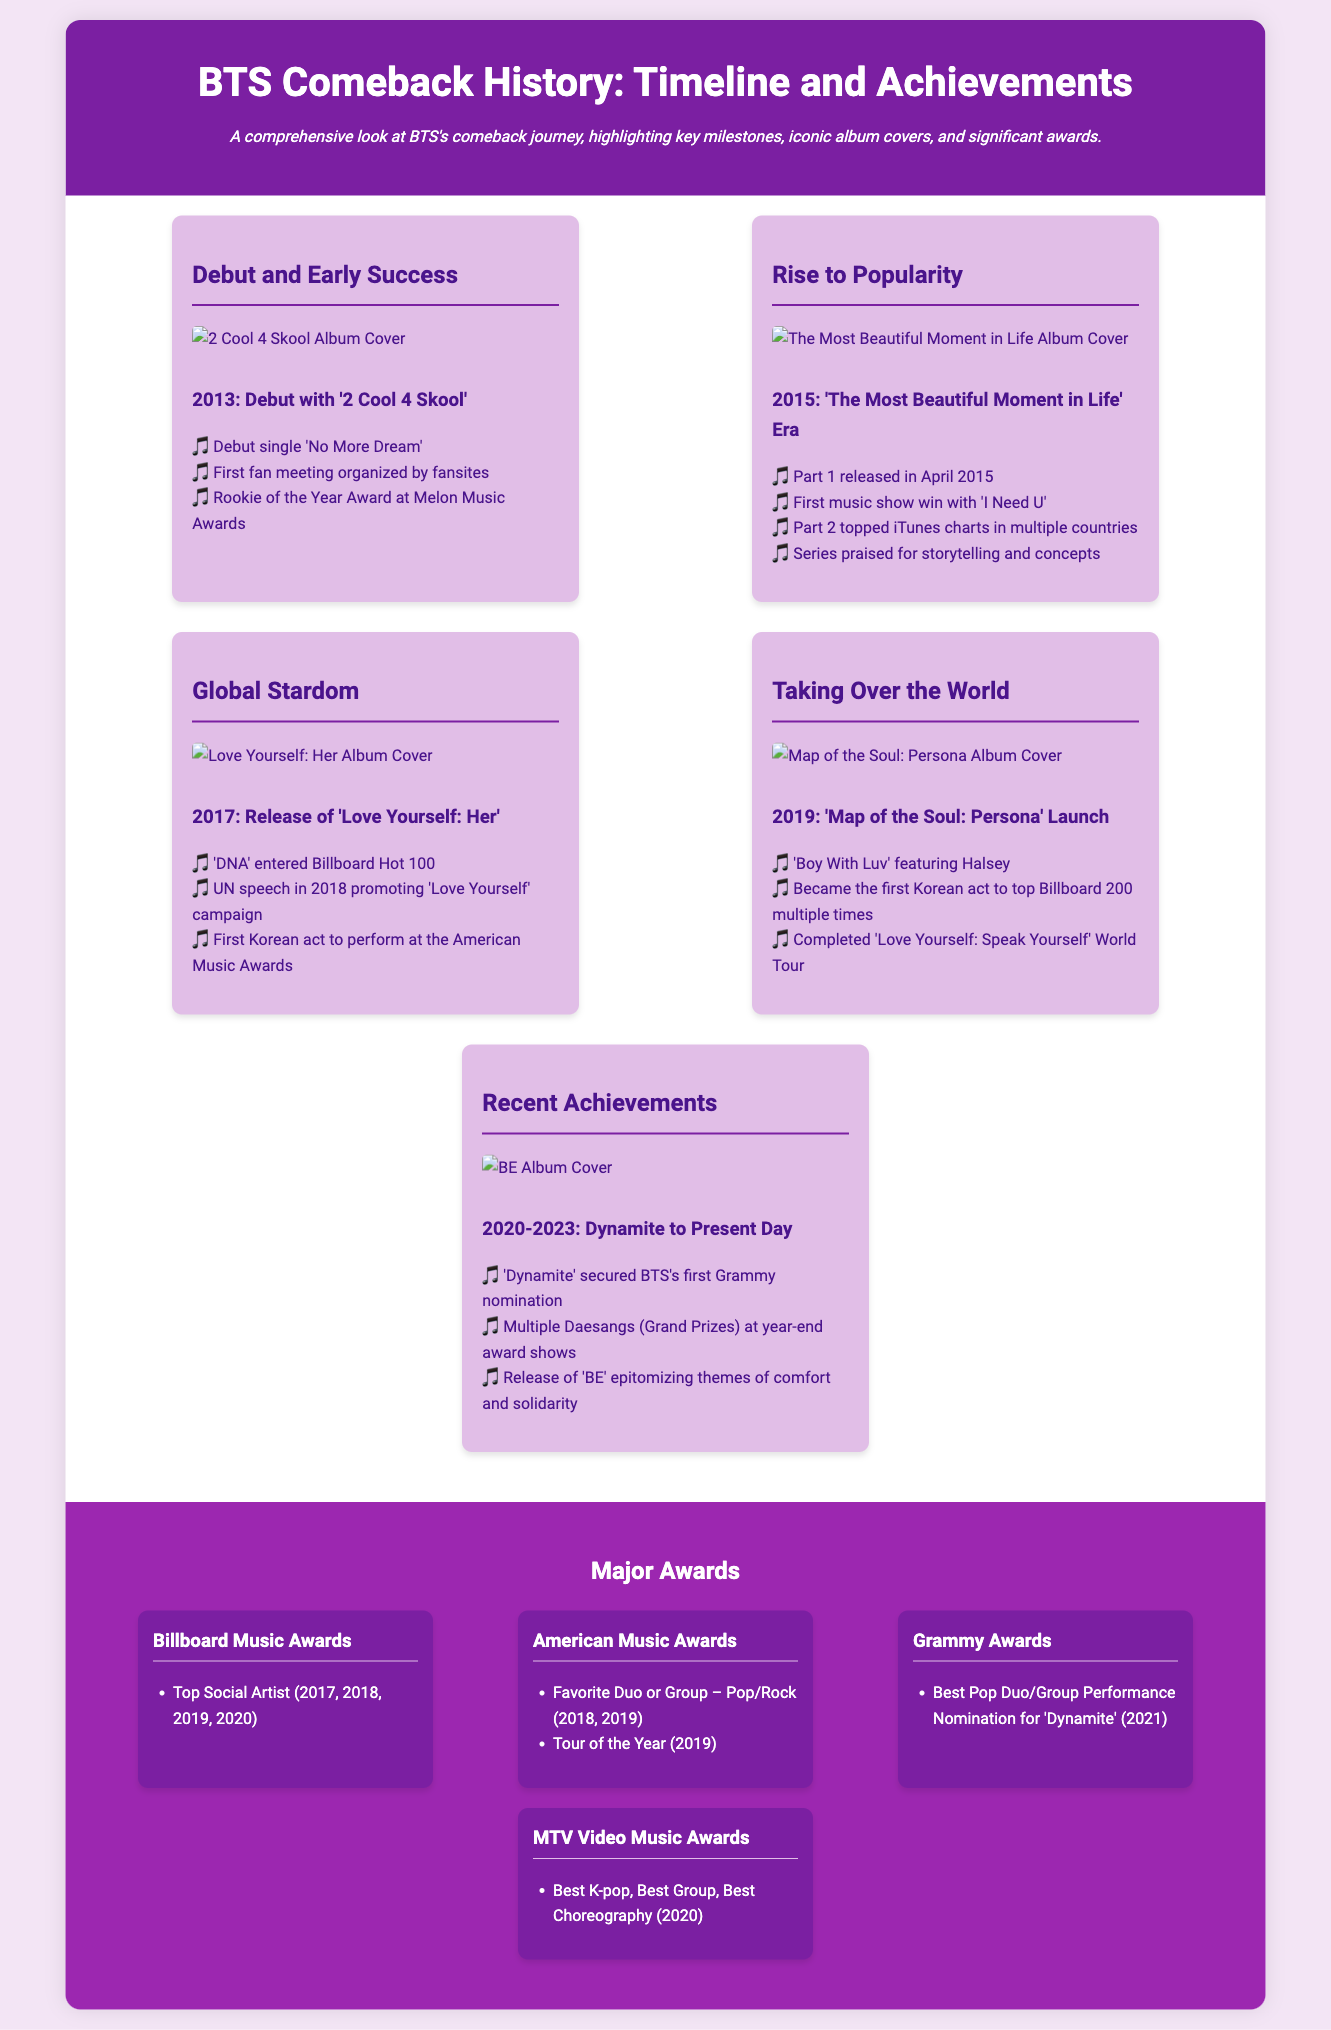What year did BTS debut? BTS debuted in 2013 with the album '2 Cool 4 Skool'.
Answer: 2013 What was the first music show win for BTS? The first music show win for BTS was with the song 'I Need U' during the 'The Most Beautiful Moment in Life' era.
Answer: 'I Need U' Which album features the song 'Boy With Luv'? 'Boy With Luv' featuring Halsey is part of the 'Map of the Soul: Persona' album released in 2019.
Answer: Map of the Soul: Persona What significant award did BTS receive in 2019? In 2019, BTS completed the 'Love Yourself: Speak Yourself' World Tour, solidifying their global presence.
Answer: Love Yourself: Speak Yourself World Tour How many times did BTS win the Top Social Artist award at the Billboard Music Awards? BTS won the Top Social Artist award four times at the Billboard Music Awards from 2017 to 2020.
Answer: Four times What campaign did BTS promote during their UN speech? BTS promoted the 'Love Yourself' campaign during their UN speech in 2018.
Answer: Love Yourself What is the theme of the album 'BE'? The album 'BE' released in 2020 epitomizes themes of comfort and solidarity.
Answer: Comfort and solidarity When was BTS's first Grammy nomination? BTS's first Grammy nomination was for the song 'Dynamite' in 2021.
Answer: 2021 Which era includes the release of 'Dynamite'? The era encompassing the release of 'Dynamite' extends from 2020 to the present day.
Answer: 2020-Present Day 